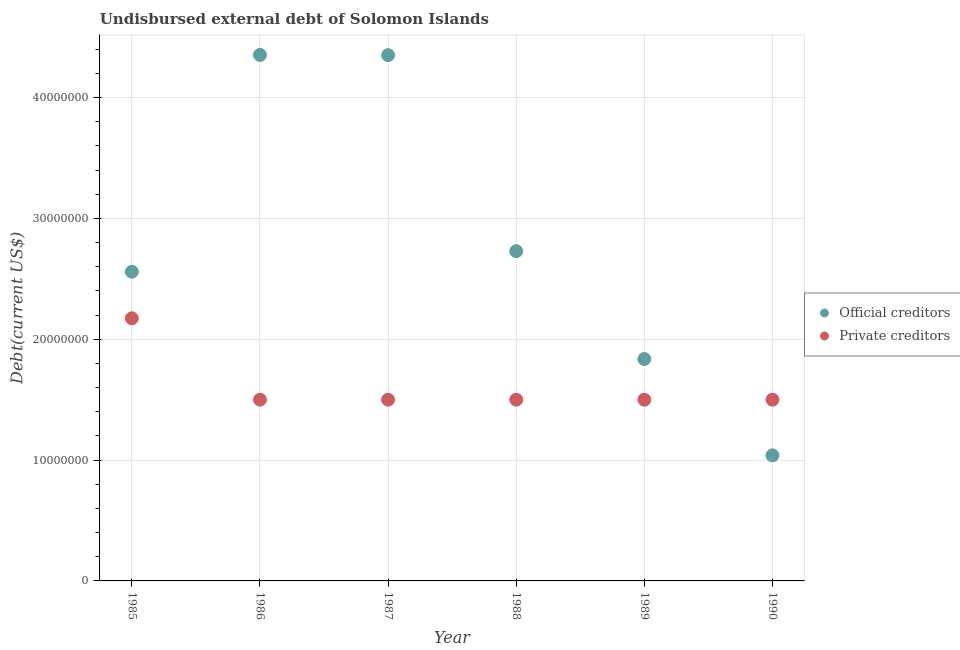How many different coloured dotlines are there?
Provide a succinct answer. 2. What is the undisbursed external debt of private creditors in 1985?
Keep it short and to the point. 2.17e+07. Across all years, what is the maximum undisbursed external debt of official creditors?
Make the answer very short. 4.35e+07. Across all years, what is the minimum undisbursed external debt of private creditors?
Keep it short and to the point. 1.50e+07. In which year was the undisbursed external debt of official creditors maximum?
Your answer should be very brief. 1986. In which year was the undisbursed external debt of official creditors minimum?
Keep it short and to the point. 1990. What is the total undisbursed external debt of private creditors in the graph?
Ensure brevity in your answer.  9.67e+07. What is the difference between the undisbursed external debt of official creditors in 1987 and that in 1990?
Ensure brevity in your answer.  3.31e+07. What is the difference between the undisbursed external debt of official creditors in 1987 and the undisbursed external debt of private creditors in 1986?
Your answer should be very brief. 2.85e+07. What is the average undisbursed external debt of official creditors per year?
Make the answer very short. 2.81e+07. In the year 1990, what is the difference between the undisbursed external debt of official creditors and undisbursed external debt of private creditors?
Provide a short and direct response. -4.61e+06. What is the ratio of the undisbursed external debt of private creditors in 1985 to that in 1987?
Offer a terse response. 1.45. What is the difference between the highest and the second highest undisbursed external debt of private creditors?
Offer a terse response. 6.74e+06. What is the difference between the highest and the lowest undisbursed external debt of private creditors?
Make the answer very short. 6.74e+06. Is the sum of the undisbursed external debt of private creditors in 1988 and 1990 greater than the maximum undisbursed external debt of official creditors across all years?
Your answer should be compact. No. Does the undisbursed external debt of official creditors monotonically increase over the years?
Ensure brevity in your answer.  No. Is the undisbursed external debt of private creditors strictly greater than the undisbursed external debt of official creditors over the years?
Your response must be concise. No. Is the undisbursed external debt of official creditors strictly less than the undisbursed external debt of private creditors over the years?
Provide a succinct answer. No. Are the values on the major ticks of Y-axis written in scientific E-notation?
Offer a terse response. No. Does the graph contain grids?
Provide a succinct answer. Yes. How are the legend labels stacked?
Your response must be concise. Vertical. What is the title of the graph?
Offer a terse response. Undisbursed external debt of Solomon Islands. Does "Exports" appear as one of the legend labels in the graph?
Give a very brief answer. No. What is the label or title of the X-axis?
Ensure brevity in your answer.  Year. What is the label or title of the Y-axis?
Your answer should be compact. Debt(current US$). What is the Debt(current US$) of Official creditors in 1985?
Your answer should be compact. 2.56e+07. What is the Debt(current US$) of Private creditors in 1985?
Ensure brevity in your answer.  2.17e+07. What is the Debt(current US$) in Official creditors in 1986?
Offer a very short reply. 4.35e+07. What is the Debt(current US$) of Private creditors in 1986?
Make the answer very short. 1.50e+07. What is the Debt(current US$) of Official creditors in 1987?
Ensure brevity in your answer.  4.35e+07. What is the Debt(current US$) of Private creditors in 1987?
Your response must be concise. 1.50e+07. What is the Debt(current US$) of Official creditors in 1988?
Keep it short and to the point. 2.73e+07. What is the Debt(current US$) of Private creditors in 1988?
Your answer should be compact. 1.50e+07. What is the Debt(current US$) in Official creditors in 1989?
Provide a succinct answer. 1.84e+07. What is the Debt(current US$) in Private creditors in 1989?
Your answer should be compact. 1.50e+07. What is the Debt(current US$) in Official creditors in 1990?
Keep it short and to the point. 1.04e+07. What is the Debt(current US$) of Private creditors in 1990?
Ensure brevity in your answer.  1.50e+07. Across all years, what is the maximum Debt(current US$) in Official creditors?
Offer a very short reply. 4.35e+07. Across all years, what is the maximum Debt(current US$) in Private creditors?
Provide a succinct answer. 2.17e+07. Across all years, what is the minimum Debt(current US$) in Official creditors?
Your response must be concise. 1.04e+07. Across all years, what is the minimum Debt(current US$) in Private creditors?
Offer a terse response. 1.50e+07. What is the total Debt(current US$) of Official creditors in the graph?
Ensure brevity in your answer.  1.69e+08. What is the total Debt(current US$) in Private creditors in the graph?
Your response must be concise. 9.67e+07. What is the difference between the Debt(current US$) of Official creditors in 1985 and that in 1986?
Keep it short and to the point. -1.79e+07. What is the difference between the Debt(current US$) of Private creditors in 1985 and that in 1986?
Keep it short and to the point. 6.74e+06. What is the difference between the Debt(current US$) of Official creditors in 1985 and that in 1987?
Give a very brief answer. -1.79e+07. What is the difference between the Debt(current US$) of Private creditors in 1985 and that in 1987?
Your answer should be very brief. 6.74e+06. What is the difference between the Debt(current US$) of Official creditors in 1985 and that in 1988?
Your answer should be compact. -1.70e+06. What is the difference between the Debt(current US$) of Private creditors in 1985 and that in 1988?
Your answer should be compact. 6.74e+06. What is the difference between the Debt(current US$) in Official creditors in 1985 and that in 1989?
Provide a succinct answer. 7.23e+06. What is the difference between the Debt(current US$) of Private creditors in 1985 and that in 1989?
Offer a terse response. 6.74e+06. What is the difference between the Debt(current US$) in Official creditors in 1985 and that in 1990?
Your response must be concise. 1.52e+07. What is the difference between the Debt(current US$) in Private creditors in 1985 and that in 1990?
Ensure brevity in your answer.  6.74e+06. What is the difference between the Debt(current US$) of Official creditors in 1986 and that in 1987?
Your response must be concise. 2.10e+04. What is the difference between the Debt(current US$) of Official creditors in 1986 and that in 1988?
Provide a succinct answer. 1.62e+07. What is the difference between the Debt(current US$) of Private creditors in 1986 and that in 1988?
Give a very brief answer. 0. What is the difference between the Debt(current US$) of Official creditors in 1986 and that in 1989?
Offer a terse response. 2.52e+07. What is the difference between the Debt(current US$) in Private creditors in 1986 and that in 1989?
Make the answer very short. 0. What is the difference between the Debt(current US$) in Official creditors in 1986 and that in 1990?
Your answer should be compact. 3.31e+07. What is the difference between the Debt(current US$) of Private creditors in 1986 and that in 1990?
Give a very brief answer. 0. What is the difference between the Debt(current US$) of Official creditors in 1987 and that in 1988?
Offer a very short reply. 1.62e+07. What is the difference between the Debt(current US$) in Official creditors in 1987 and that in 1989?
Your answer should be compact. 2.51e+07. What is the difference between the Debt(current US$) of Private creditors in 1987 and that in 1989?
Ensure brevity in your answer.  0. What is the difference between the Debt(current US$) of Official creditors in 1987 and that in 1990?
Offer a terse response. 3.31e+07. What is the difference between the Debt(current US$) in Private creditors in 1987 and that in 1990?
Your answer should be compact. 0. What is the difference between the Debt(current US$) in Official creditors in 1988 and that in 1989?
Make the answer very short. 8.93e+06. What is the difference between the Debt(current US$) of Official creditors in 1988 and that in 1990?
Provide a succinct answer. 1.69e+07. What is the difference between the Debt(current US$) in Private creditors in 1988 and that in 1990?
Keep it short and to the point. 0. What is the difference between the Debt(current US$) in Official creditors in 1989 and that in 1990?
Keep it short and to the point. 7.98e+06. What is the difference between the Debt(current US$) of Private creditors in 1989 and that in 1990?
Your response must be concise. 0. What is the difference between the Debt(current US$) in Official creditors in 1985 and the Debt(current US$) in Private creditors in 1986?
Your answer should be very brief. 1.06e+07. What is the difference between the Debt(current US$) of Official creditors in 1985 and the Debt(current US$) of Private creditors in 1987?
Your answer should be very brief. 1.06e+07. What is the difference between the Debt(current US$) of Official creditors in 1985 and the Debt(current US$) of Private creditors in 1988?
Ensure brevity in your answer.  1.06e+07. What is the difference between the Debt(current US$) in Official creditors in 1985 and the Debt(current US$) in Private creditors in 1989?
Give a very brief answer. 1.06e+07. What is the difference between the Debt(current US$) in Official creditors in 1985 and the Debt(current US$) in Private creditors in 1990?
Provide a short and direct response. 1.06e+07. What is the difference between the Debt(current US$) in Official creditors in 1986 and the Debt(current US$) in Private creditors in 1987?
Keep it short and to the point. 2.85e+07. What is the difference between the Debt(current US$) in Official creditors in 1986 and the Debt(current US$) in Private creditors in 1988?
Keep it short and to the point. 2.85e+07. What is the difference between the Debt(current US$) in Official creditors in 1986 and the Debt(current US$) in Private creditors in 1989?
Provide a short and direct response. 2.85e+07. What is the difference between the Debt(current US$) of Official creditors in 1986 and the Debt(current US$) of Private creditors in 1990?
Your response must be concise. 2.85e+07. What is the difference between the Debt(current US$) of Official creditors in 1987 and the Debt(current US$) of Private creditors in 1988?
Give a very brief answer. 2.85e+07. What is the difference between the Debt(current US$) in Official creditors in 1987 and the Debt(current US$) in Private creditors in 1989?
Ensure brevity in your answer.  2.85e+07. What is the difference between the Debt(current US$) in Official creditors in 1987 and the Debt(current US$) in Private creditors in 1990?
Your answer should be compact. 2.85e+07. What is the difference between the Debt(current US$) in Official creditors in 1988 and the Debt(current US$) in Private creditors in 1989?
Your answer should be compact. 1.23e+07. What is the difference between the Debt(current US$) of Official creditors in 1988 and the Debt(current US$) of Private creditors in 1990?
Your answer should be compact. 1.23e+07. What is the difference between the Debt(current US$) of Official creditors in 1989 and the Debt(current US$) of Private creditors in 1990?
Offer a terse response. 3.37e+06. What is the average Debt(current US$) of Official creditors per year?
Provide a short and direct response. 2.81e+07. What is the average Debt(current US$) in Private creditors per year?
Offer a terse response. 1.61e+07. In the year 1985, what is the difference between the Debt(current US$) of Official creditors and Debt(current US$) of Private creditors?
Ensure brevity in your answer.  3.86e+06. In the year 1986, what is the difference between the Debt(current US$) in Official creditors and Debt(current US$) in Private creditors?
Offer a very short reply. 2.85e+07. In the year 1987, what is the difference between the Debt(current US$) of Official creditors and Debt(current US$) of Private creditors?
Ensure brevity in your answer.  2.85e+07. In the year 1988, what is the difference between the Debt(current US$) in Official creditors and Debt(current US$) in Private creditors?
Your answer should be compact. 1.23e+07. In the year 1989, what is the difference between the Debt(current US$) of Official creditors and Debt(current US$) of Private creditors?
Make the answer very short. 3.37e+06. In the year 1990, what is the difference between the Debt(current US$) in Official creditors and Debt(current US$) in Private creditors?
Provide a short and direct response. -4.61e+06. What is the ratio of the Debt(current US$) in Official creditors in 1985 to that in 1986?
Provide a short and direct response. 0.59. What is the ratio of the Debt(current US$) in Private creditors in 1985 to that in 1986?
Provide a succinct answer. 1.45. What is the ratio of the Debt(current US$) of Official creditors in 1985 to that in 1987?
Give a very brief answer. 0.59. What is the ratio of the Debt(current US$) in Private creditors in 1985 to that in 1987?
Your answer should be very brief. 1.45. What is the ratio of the Debt(current US$) of Official creditors in 1985 to that in 1988?
Offer a terse response. 0.94. What is the ratio of the Debt(current US$) of Private creditors in 1985 to that in 1988?
Make the answer very short. 1.45. What is the ratio of the Debt(current US$) in Official creditors in 1985 to that in 1989?
Ensure brevity in your answer.  1.39. What is the ratio of the Debt(current US$) in Private creditors in 1985 to that in 1989?
Offer a very short reply. 1.45. What is the ratio of the Debt(current US$) of Official creditors in 1985 to that in 1990?
Offer a very short reply. 2.46. What is the ratio of the Debt(current US$) in Private creditors in 1985 to that in 1990?
Your answer should be very brief. 1.45. What is the ratio of the Debt(current US$) in Official creditors in 1986 to that in 1987?
Offer a terse response. 1. What is the ratio of the Debt(current US$) in Private creditors in 1986 to that in 1987?
Make the answer very short. 1. What is the ratio of the Debt(current US$) in Official creditors in 1986 to that in 1988?
Your answer should be compact. 1.6. What is the ratio of the Debt(current US$) of Private creditors in 1986 to that in 1988?
Your answer should be compact. 1. What is the ratio of the Debt(current US$) of Official creditors in 1986 to that in 1989?
Your answer should be very brief. 2.37. What is the ratio of the Debt(current US$) of Official creditors in 1986 to that in 1990?
Your response must be concise. 4.19. What is the ratio of the Debt(current US$) in Private creditors in 1986 to that in 1990?
Make the answer very short. 1. What is the ratio of the Debt(current US$) in Official creditors in 1987 to that in 1988?
Offer a terse response. 1.59. What is the ratio of the Debt(current US$) in Official creditors in 1987 to that in 1989?
Keep it short and to the point. 2.37. What is the ratio of the Debt(current US$) of Official creditors in 1987 to that in 1990?
Offer a terse response. 4.19. What is the ratio of the Debt(current US$) in Private creditors in 1987 to that in 1990?
Give a very brief answer. 1. What is the ratio of the Debt(current US$) of Official creditors in 1988 to that in 1989?
Provide a short and direct response. 1.49. What is the ratio of the Debt(current US$) of Private creditors in 1988 to that in 1989?
Provide a succinct answer. 1. What is the ratio of the Debt(current US$) in Official creditors in 1988 to that in 1990?
Give a very brief answer. 2.63. What is the ratio of the Debt(current US$) in Official creditors in 1989 to that in 1990?
Your answer should be very brief. 1.77. What is the difference between the highest and the second highest Debt(current US$) in Official creditors?
Provide a succinct answer. 2.10e+04. What is the difference between the highest and the second highest Debt(current US$) of Private creditors?
Offer a very short reply. 6.74e+06. What is the difference between the highest and the lowest Debt(current US$) of Official creditors?
Your answer should be very brief. 3.31e+07. What is the difference between the highest and the lowest Debt(current US$) of Private creditors?
Offer a very short reply. 6.74e+06. 